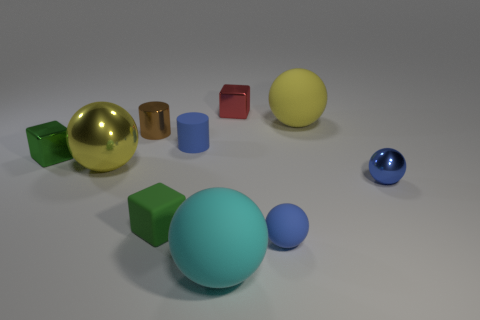How many blue spheres must be subtracted to get 1 blue spheres? 1 Subtract all shiny cubes. How many cubes are left? 1 Subtract 1 blocks. How many blocks are left? 2 Subtract all red cubes. How many cubes are left? 2 Subtract all cylinders. How many objects are left? 8 Subtract all blue blocks. Subtract all purple spheres. How many blocks are left? 3 Subtract all blue cylinders. How many yellow balls are left? 2 Subtract all red objects. Subtract all green matte cubes. How many objects are left? 8 Add 8 green metallic things. How many green metallic things are left? 9 Add 7 tiny brown metal blocks. How many tiny brown metal blocks exist? 7 